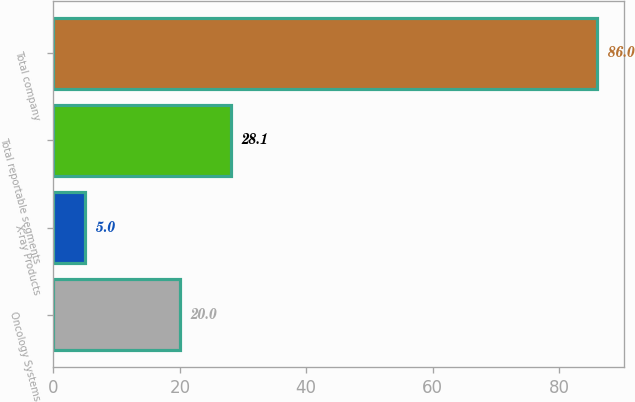Convert chart. <chart><loc_0><loc_0><loc_500><loc_500><bar_chart><fcel>Oncology Systems<fcel>X-ray Products<fcel>Total reportable segments<fcel>Total company<nl><fcel>20<fcel>5<fcel>28.1<fcel>86<nl></chart> 